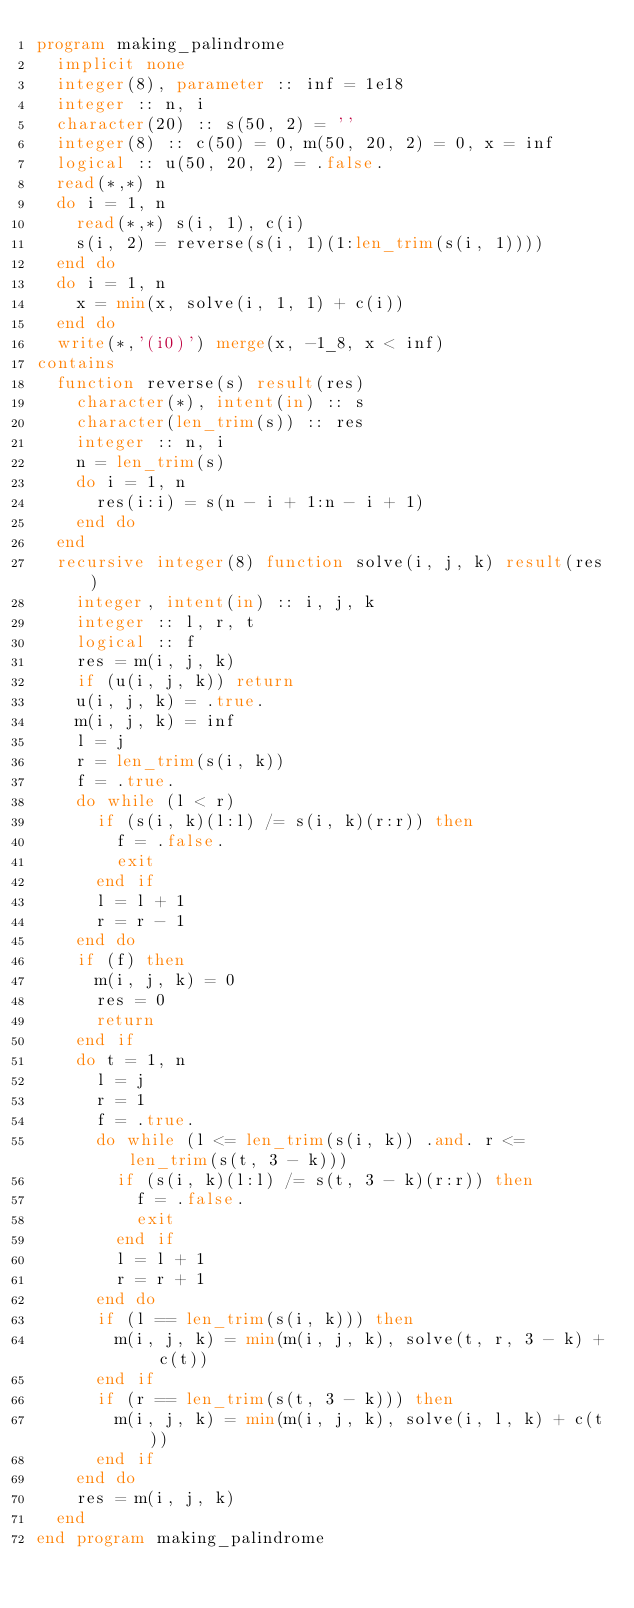<code> <loc_0><loc_0><loc_500><loc_500><_FORTRAN_>program making_palindrome
  implicit none
  integer(8), parameter :: inf = 1e18
  integer :: n, i
  character(20) :: s(50, 2) = ''
  integer(8) :: c(50) = 0, m(50, 20, 2) = 0, x = inf
  logical :: u(50, 20, 2) = .false.
  read(*,*) n
  do i = 1, n
    read(*,*) s(i, 1), c(i)
    s(i, 2) = reverse(s(i, 1)(1:len_trim(s(i, 1))))
  end do
  do i = 1, n
    x = min(x, solve(i, 1, 1) + c(i))
  end do
  write(*,'(i0)') merge(x, -1_8, x < inf)
contains
  function reverse(s) result(res)
    character(*), intent(in) :: s
    character(len_trim(s)) :: res
    integer :: n, i
    n = len_trim(s)
    do i = 1, n
      res(i:i) = s(n - i + 1:n - i + 1)
    end do
  end
  recursive integer(8) function solve(i, j, k) result(res)
    integer, intent(in) :: i, j, k
    integer :: l, r, t
    logical :: f
    res = m(i, j, k)
    if (u(i, j, k)) return
    u(i, j, k) = .true.
    m(i, j, k) = inf
    l = j
    r = len_trim(s(i, k))
    f = .true.
    do while (l < r)
      if (s(i, k)(l:l) /= s(i, k)(r:r)) then
        f = .false.
        exit
      end if
      l = l + 1
      r = r - 1
    end do
    if (f) then
      m(i, j, k) = 0
      res = 0
      return
    end if
    do t = 1, n
      l = j
      r = 1
      f = .true.
      do while (l <= len_trim(s(i, k)) .and. r <= len_trim(s(t, 3 - k)))
        if (s(i, k)(l:l) /= s(t, 3 - k)(r:r)) then
          f = .false.
          exit
        end if
        l = l + 1
        r = r + 1
      end do
      if (l == len_trim(s(i, k))) then
        m(i, j, k) = min(m(i, j, k), solve(t, r, 3 - k) + c(t))
      end if
      if (r == len_trim(s(t, 3 - k))) then
        m(i, j, k) = min(m(i, j, k), solve(i, l, k) + c(t))
      end if
    end do
    res = m(i, j, k)
  end
end program making_palindrome</code> 